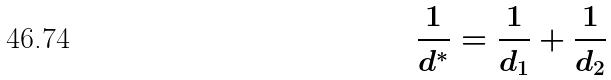<formula> <loc_0><loc_0><loc_500><loc_500>\frac { 1 } { d ^ { * } } = \frac { 1 } { d _ { 1 } } + \frac { 1 } { d _ { 2 } }</formula> 